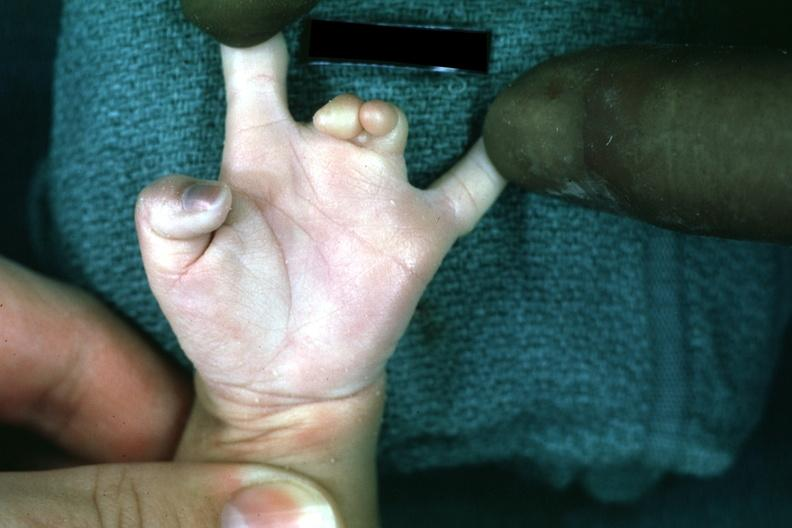does adrenal of premature 30 week gestation gram infant lesion show syndactyly?
Answer the question using a single word or phrase. No 